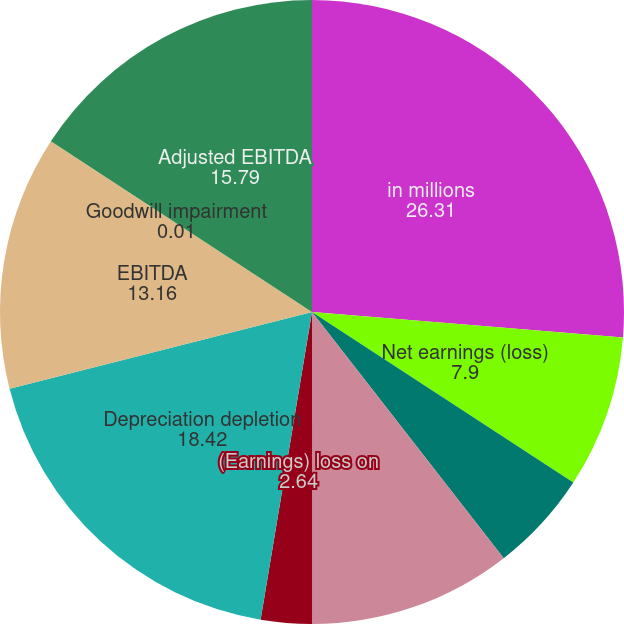Convert chart to OTSL. <chart><loc_0><loc_0><loc_500><loc_500><pie_chart><fcel>in millions<fcel>Net earnings (loss)<fcel>Provision (benefit) for income<fcel>Interest expense net<fcel>(Earnings) loss on<fcel>Depreciation depletion<fcel>EBITDA<fcel>Goodwill impairment<fcel>Adjusted EBITDA<nl><fcel>26.31%<fcel>7.9%<fcel>5.27%<fcel>10.53%<fcel>2.64%<fcel>18.42%<fcel>13.16%<fcel>0.01%<fcel>15.79%<nl></chart> 